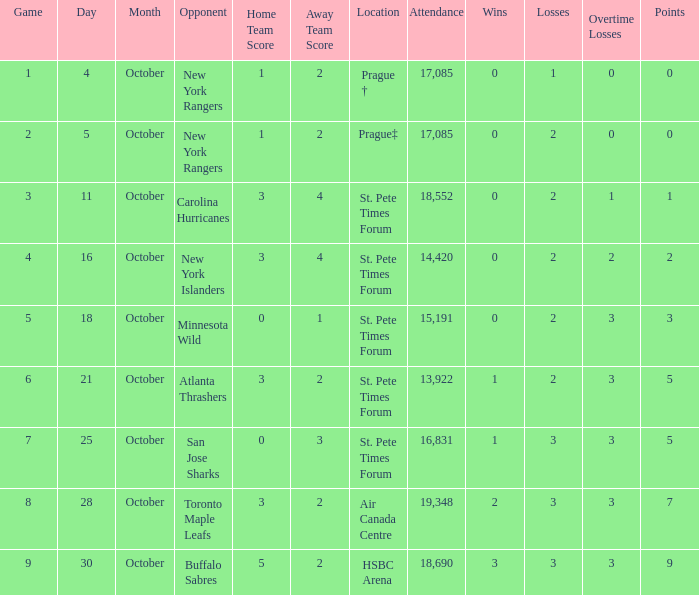What was the attendance when their record stood at 0-2-2? 14420.0. Could you parse the entire table as a dict? {'header': ['Game', 'Day', 'Month', 'Opponent', 'Home Team Score', 'Away Team Score', 'Location', 'Attendance', 'Wins', 'Losses', 'Overtime Losses', 'Points'], 'rows': [['1', '4', 'October', 'New York Rangers', '1', '2', 'Prague †', '17,085', '0', '1', '0', '0'], ['2', '5', 'October', 'New York Rangers', '1', '2', 'Prague‡', '17,085', '0', '2', '0', '0'], ['3', '11', 'October', 'Carolina Hurricanes', '3', '4', 'St. Pete Times Forum', '18,552', '0', '2', '1', '1'], ['4', '16', 'October', 'New York Islanders', '3', '4', 'St. Pete Times Forum', '14,420', '0', '2', '2', '2'], ['5', '18', 'October', 'Minnesota Wild', '0', '1', 'St. Pete Times Forum', '15,191', '0', '2', '3', '3'], ['6', '21', 'October', 'Atlanta Thrashers', '3', '2', 'St. Pete Times Forum', '13,922', '1', '2', '3', '5'], ['7', '25', 'October', 'San Jose Sharks', '0', '3', 'St. Pete Times Forum', '16,831', '1', '3', '3', '5'], ['8', '28', 'October', 'Toronto Maple Leafs', '3', '2', 'Air Canada Centre', '19,348', '2', '3', '3', '7'], ['9', '30', 'October', 'Buffalo Sabres', '5', '2', 'HSBC Arena', '18,690', '3', '3', '3', '9']]} 